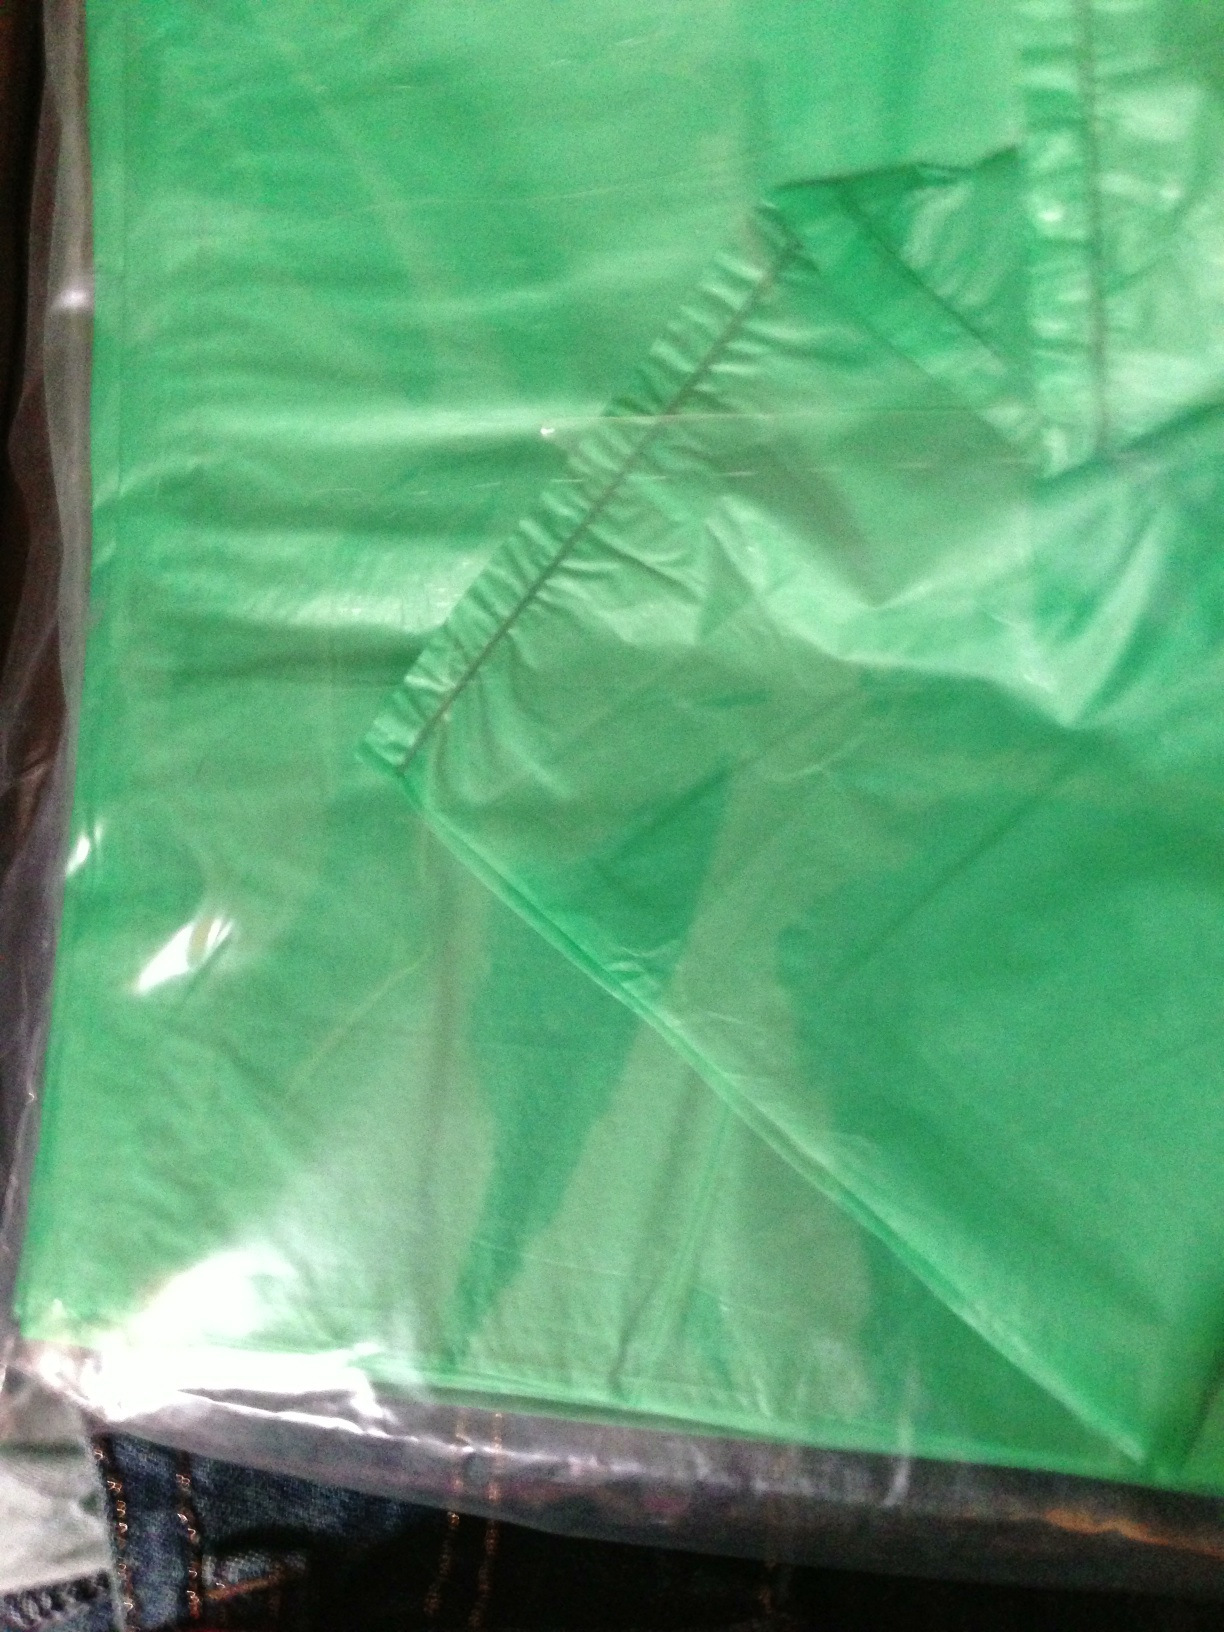Does this bag have a label on it? And if so, what does it say? The image shows a green bag, but due to the image quality and angle, discerning any labels or text on it is quite challenging. It appears there are no clearly visible labels or text; however, without a higher resolution or a different angle, I cannot provide a definitive answer about any labels or text. 